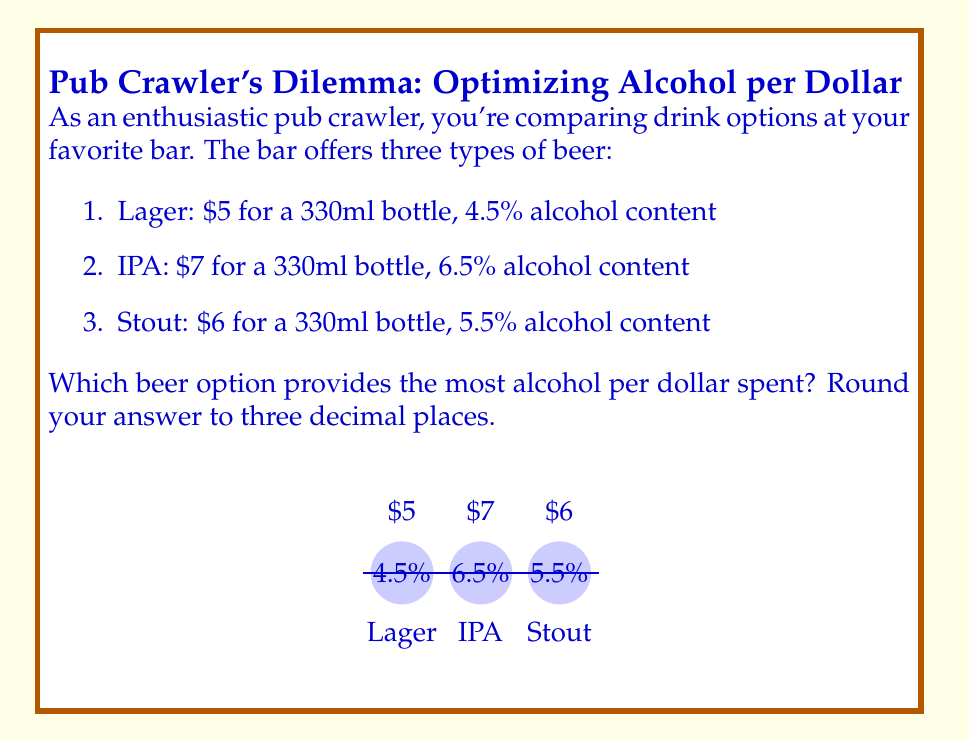Give your solution to this math problem. To determine the most cost-effective option, we need to calculate the amount of pure alcohol per dollar for each beer. Let's follow these steps:

1. Calculate the volume of pure alcohol in each beer:
   $\text{Pure alcohol} = \text{Volume} \times \text{Alcohol percentage}$

   Lager: $330 \text{ ml} \times 0.045 = 14.85 \text{ ml}$
   IPA: $330 \text{ ml} \times 0.065 = 21.45 \text{ ml}$
   Stout: $330 \text{ ml} \times 0.055 = 18.15 \text{ ml}$

2. Calculate the amount of pure alcohol per dollar:
   $\text{Alcohol per dollar} = \frac{\text{Pure alcohol}}{\text{Price}}$

   Lager: $\frac{14.85 \text{ ml}}{\$5} = 2.97 \text{ ml/\$}$
   IPA: $\frac{21.45 \text{ ml}}{\$7} = 3.064 \text{ ml/\$}$
   Stout: $\frac{18.15 \text{ ml}}{\$6} = 3.025 \text{ ml/\$}$

3. Compare the results:
   IPA provides 3.064 ml of pure alcohol per dollar
   Stout provides 3.025 ml of pure alcohol per dollar
   Lager provides 2.97 ml of pure alcohol per dollar

Therefore, the IPA offers the most alcohol per dollar spent, with 3.064 ml/$, rounded to three decimal places.
Answer: IPA (3.064 ml/$ of pure alcohol) 